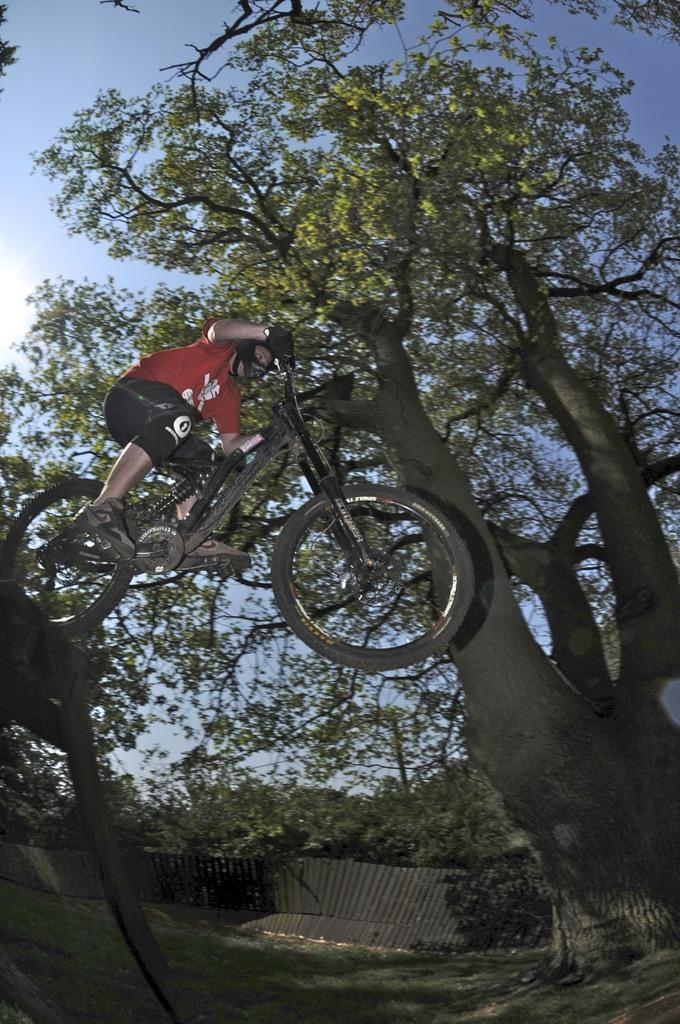Can you describe this image briefly? This is an outside view. On the left side there is a person riding the bicycle in the air. At the bottom, I can see the ground. On the right side there is a tree. In the background there is a fencing and many trees. At the top of the image I can see the sky. 